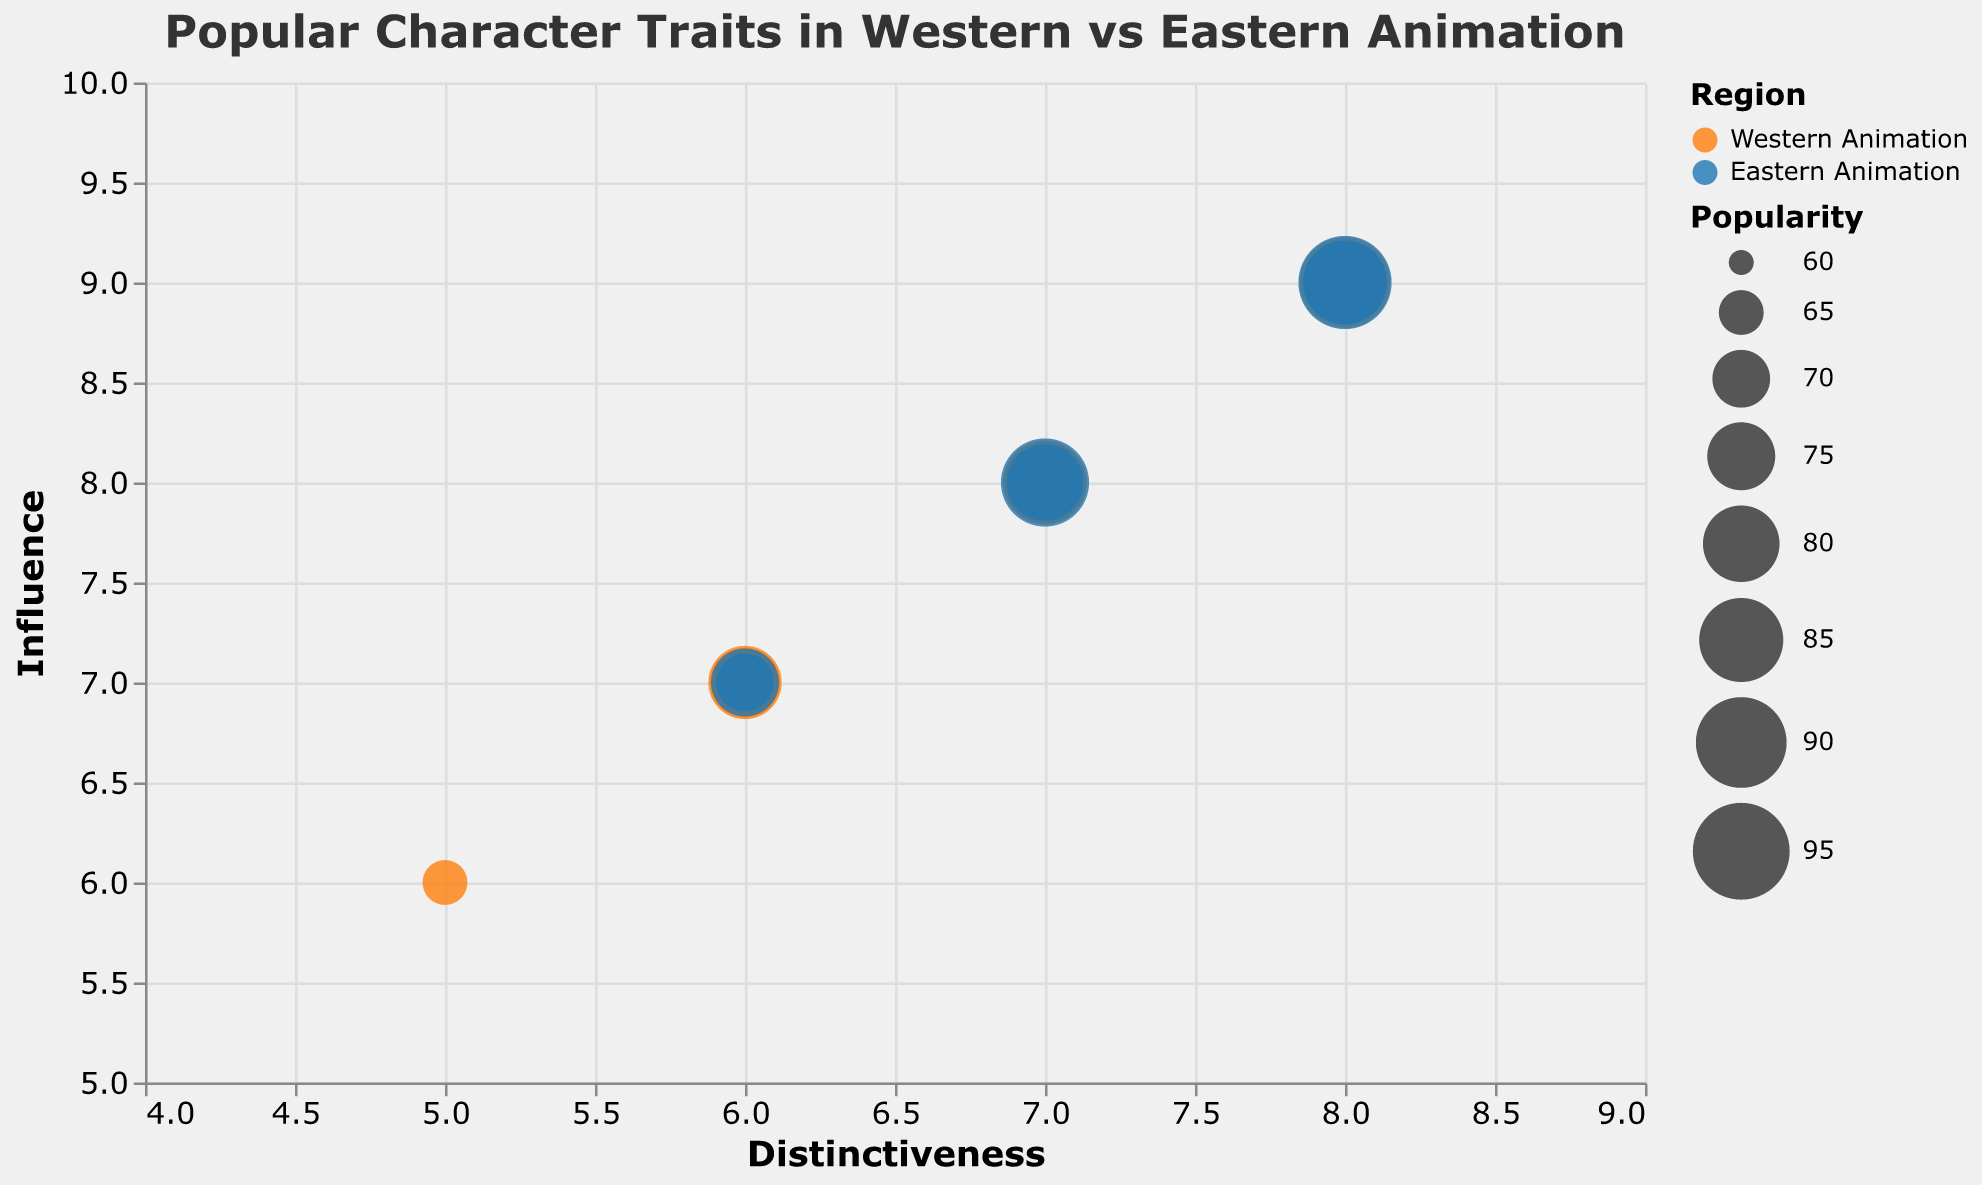What is the title of the chart? The title of the chart is displayed at the top and reads "Popular Character Traits in Western vs Eastern Animation."
Answer: Popular Character Traits in Western vs Eastern Animation What are the X and Y axes representing in the chart? The X-axis represents "Distinctiveness," and the Y-axis represents "Influence."
Answer: Distinctiveness and Influence Which trait has the highest popularity among all traits? By observing the size of the bubbles, "Perseverance" in Eastern Animation has the largest bubble, indicating the highest popularity.
Answer: Perseverance How many traits represent "Western Animation"? By counting the bubbles colored in the respective color for Western Animation, we see there are six traits.
Answer: Six traits Which region has the trait with the highest distinctiveness score? "Eastern Animation" has the highest distinctiveness score with the trait "Perseverance," which has a score of 8.
Answer: Eastern Animation What is the difference in popularity between "Courage" in Western Animation and "Sacrifice" in Eastern Animation? "Courage" has a popularity score of 85, while "Sacrifice" has 80. The difference is 85 - 80 = 5.
Answer: 5 Which region tends to have traits with higher influence scores overall? By observing the traits, "Eastern Animation" appears more often at higher Influence values on the Y-axis.
Answer: Eastern Animation Which trait has the lowest distinctiveness score and which region does it belong to? "Honor" in Western Animation has the lowest distinctiveness score of 5.
Answer: Honor, Western Animation What is the average influence score of traits in Eastern Animation? The influence scores for Eastern Animation traits are 8, 9, 7, 7, 8, 9. The sum is 48, and there are 6 traits, so the average is 48/6 = 8.
Answer: 8 Are there any traits with both high distinctiveness and influence? If so, which one? The trait "Perseverance" in Eastern Animation scores high in both dimensions with distinctiveness 8 and influence 9.
Answer: Perseverance 